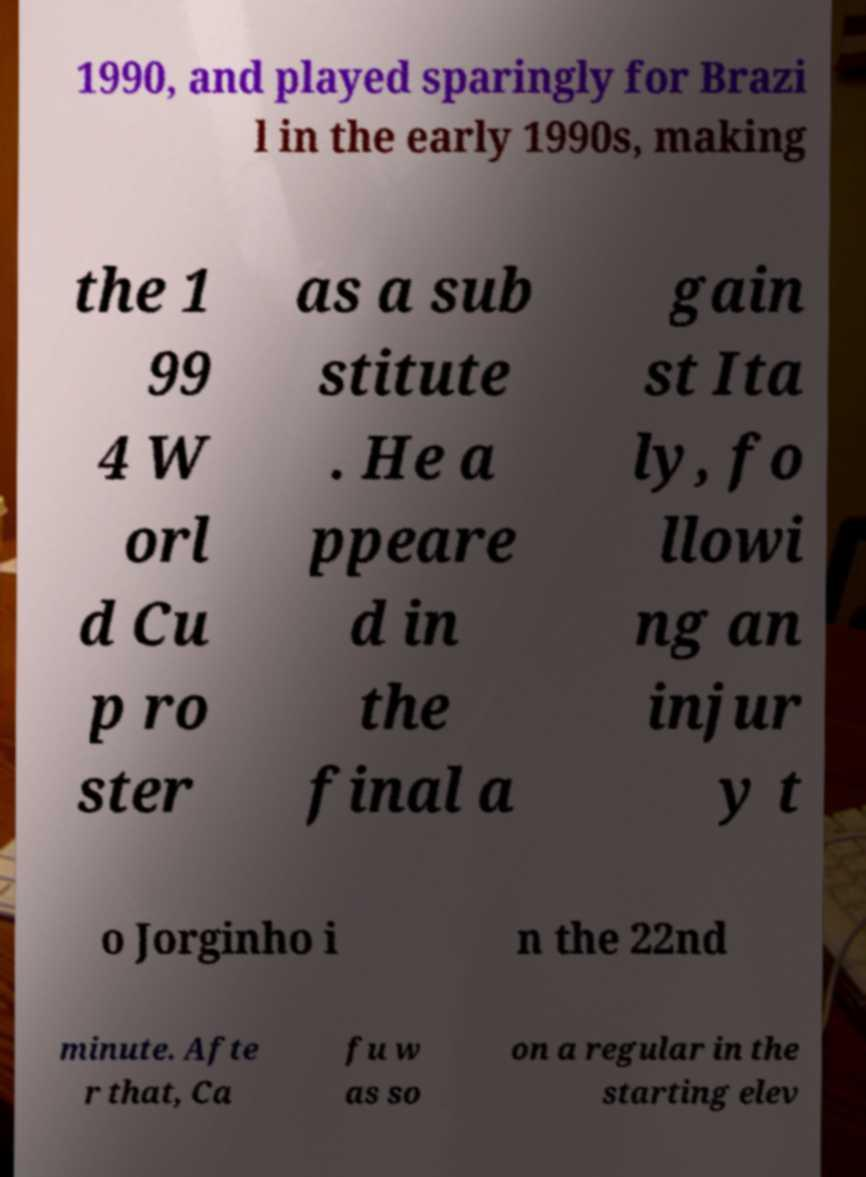I need the written content from this picture converted into text. Can you do that? 1990, and played sparingly for Brazi l in the early 1990s, making the 1 99 4 W orl d Cu p ro ster as a sub stitute . He a ppeare d in the final a gain st Ita ly, fo llowi ng an injur y t o Jorginho i n the 22nd minute. Afte r that, Ca fu w as so on a regular in the starting elev 